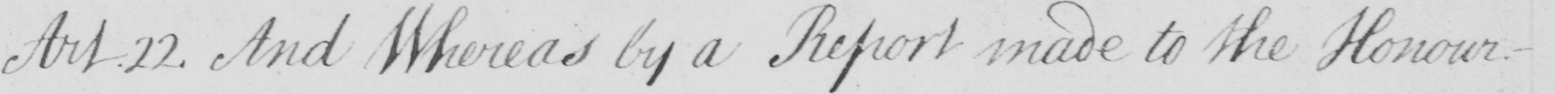Transcribe the text shown in this historical manuscript line. Art.22 . And Whereas by a Report made to the Honour- 